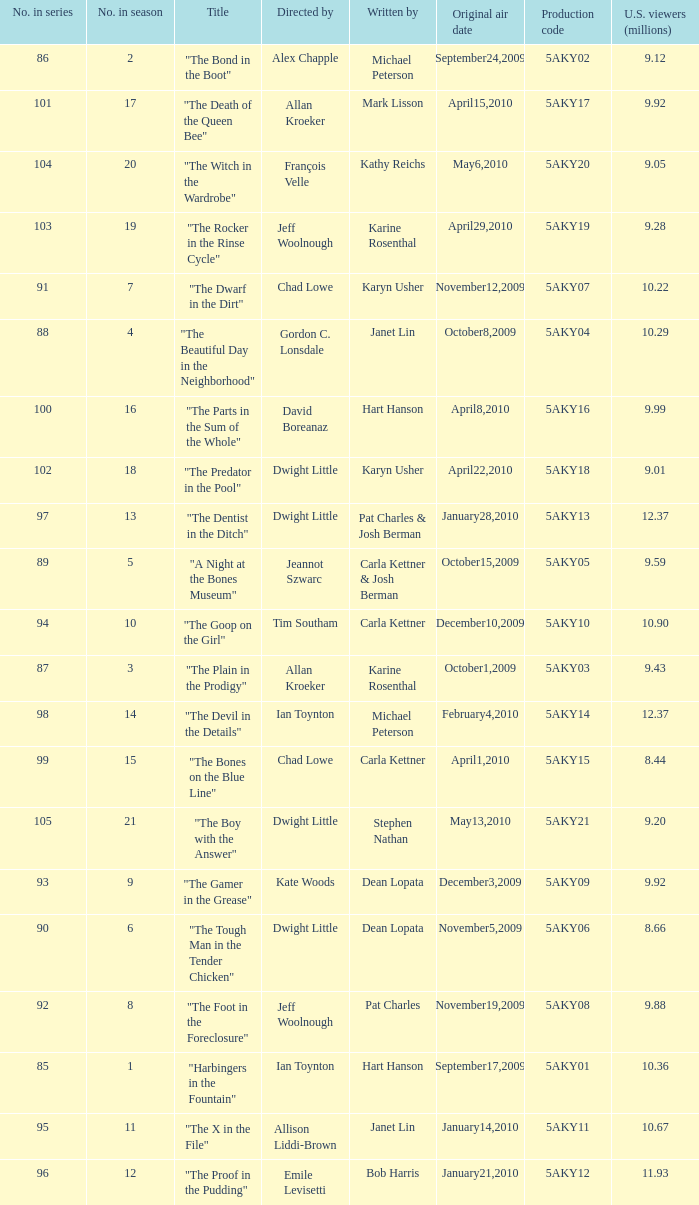How many were the US viewers (in millions) of the episode that was written by Gordon C. Lonsdale? 10.29. 